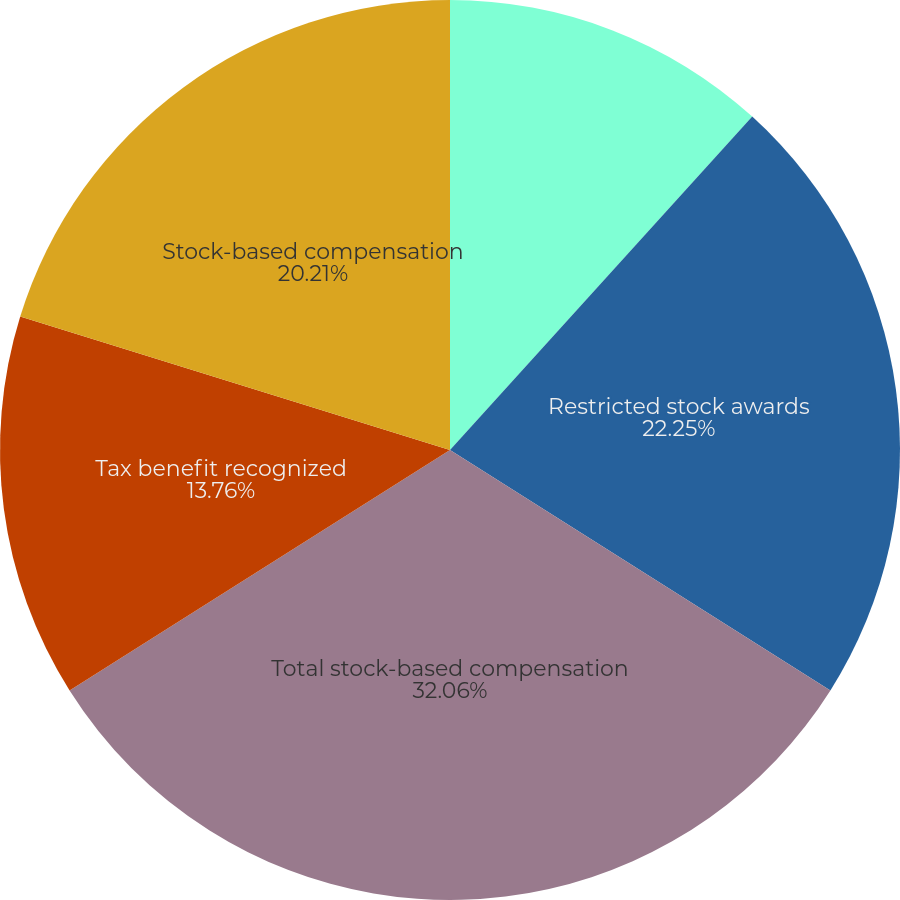<chart> <loc_0><loc_0><loc_500><loc_500><pie_chart><fcel>Stock options<fcel>Restricted stock awards<fcel>Total stock-based compensation<fcel>Tax benefit recognized<fcel>Stock-based compensation<nl><fcel>11.72%<fcel>22.25%<fcel>32.06%<fcel>13.76%<fcel>20.21%<nl></chart> 